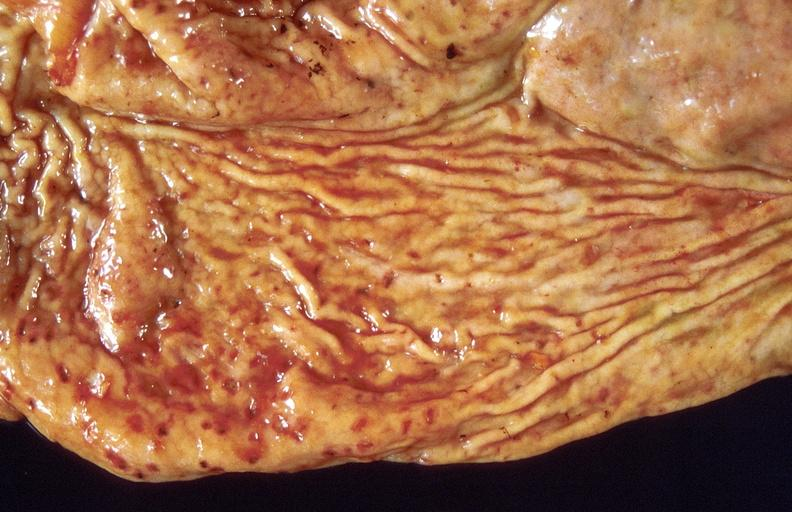s vessel present?
Answer the question using a single word or phrase. No 